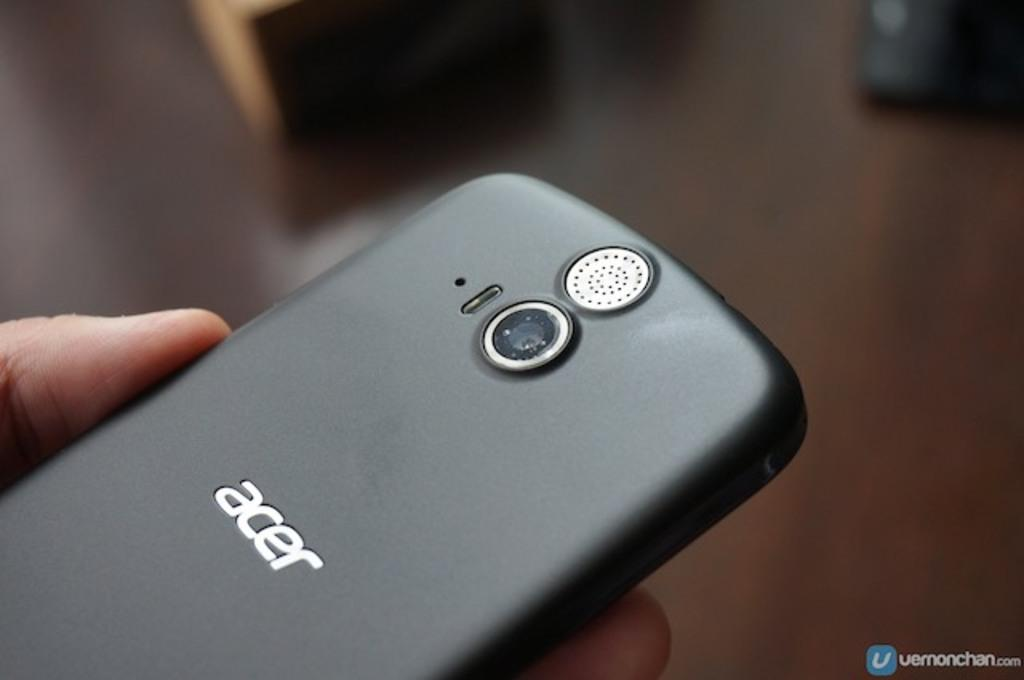What is the main subject of the image? There is a person in the image. What is the person holding in the image? The person is holding a mobile. Can you describe the background of the image? The background of the image is blurry. What else can be seen in the background of the image? There are objects visible in the background. Where is the text located in the image? The text is in the bottom right corner of the image. What type of fear can be seen on the person's face in the image? There is no indication of fear on the person's face in the image. What is the mist doing in the image? There is no mist present in the image. 